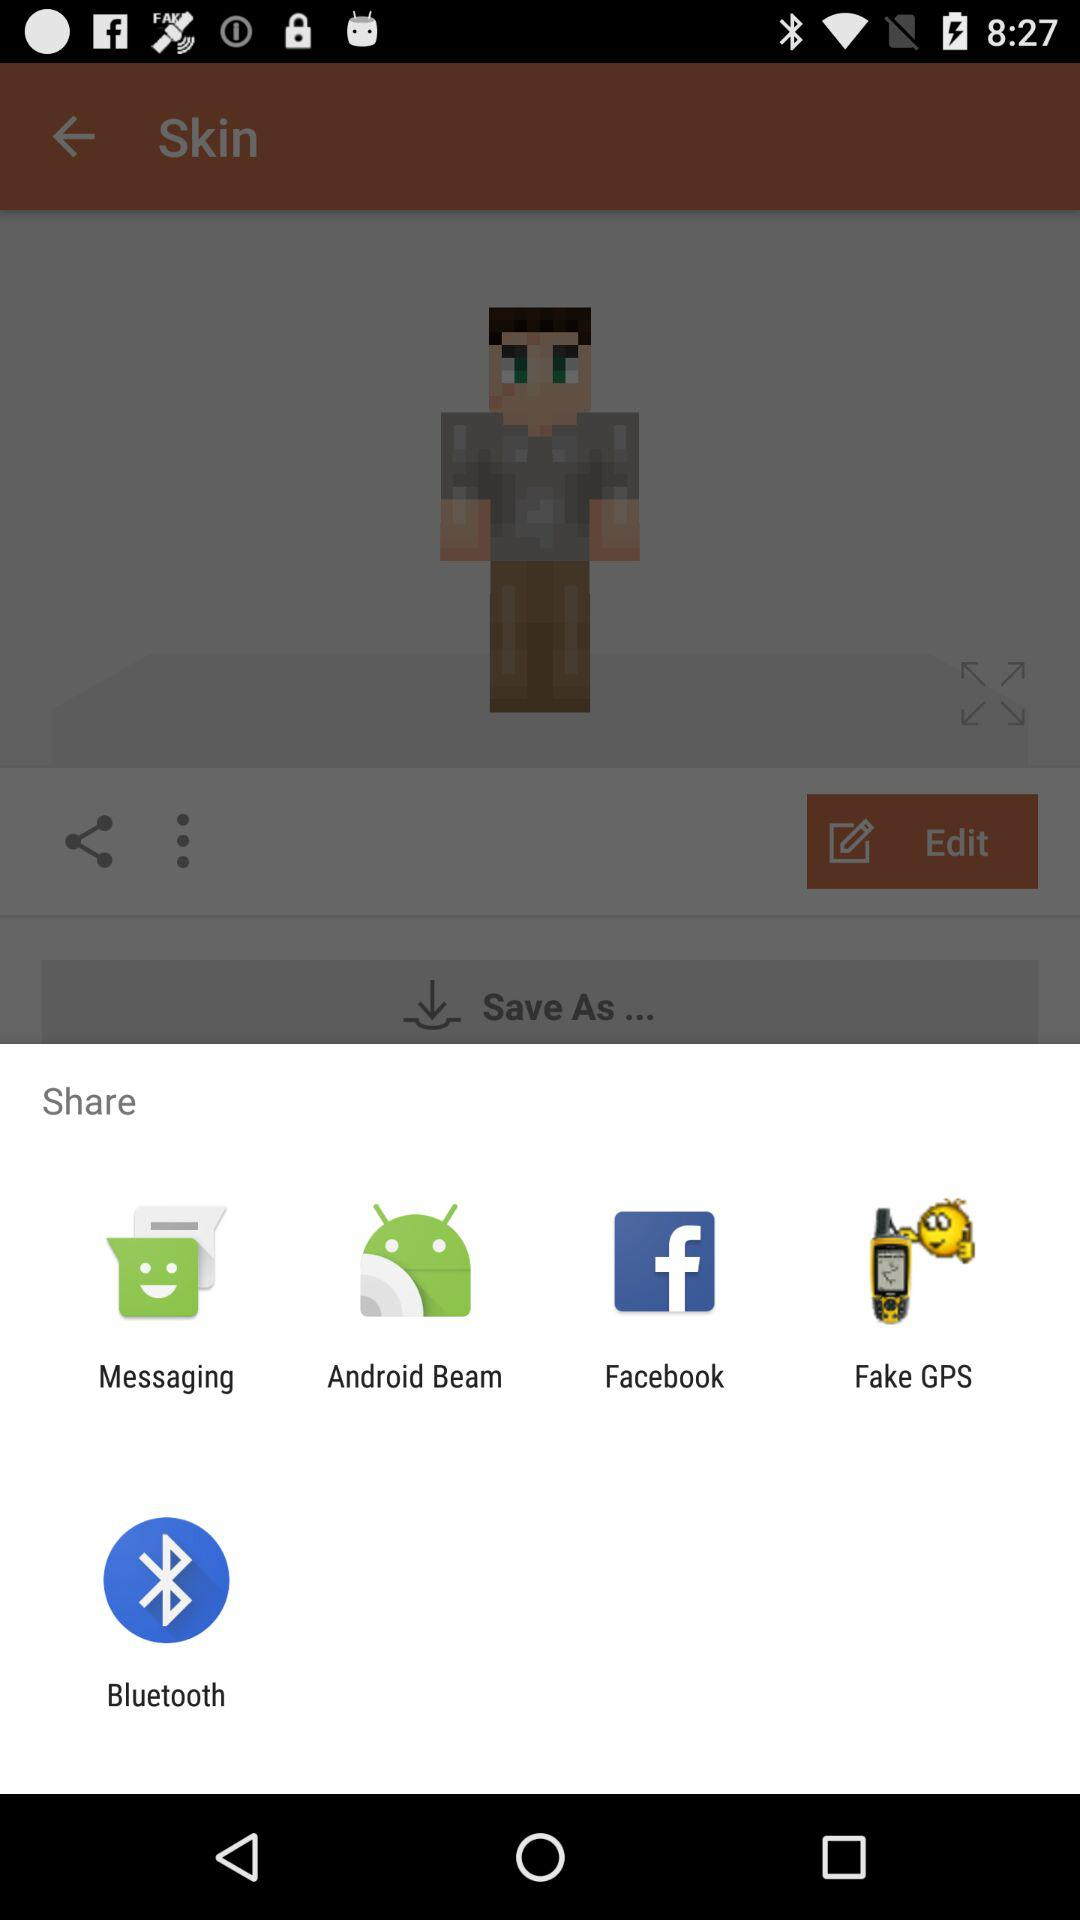Where is the skin being saved to?
When the provided information is insufficient, respond with <no answer>. <no answer> 